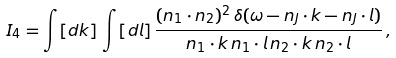<formula> <loc_0><loc_0><loc_500><loc_500>I _ { 4 } = \int [ d k ] \, \int [ d l ] \, \frac { ( n _ { 1 } \cdot n _ { 2 } ) ^ { 2 } \, \delta ( \omega - n _ { J } \cdot k - n _ { J } \cdot l ) } { n _ { 1 } \cdot k \, n _ { 1 } \cdot l \, n _ { 2 } \cdot k \, n _ { 2 } \cdot l } \, ,</formula> 